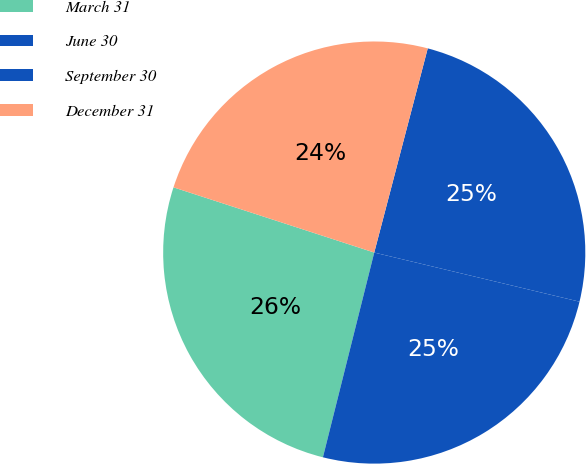Convert chart. <chart><loc_0><loc_0><loc_500><loc_500><pie_chart><fcel>March 31<fcel>June 30<fcel>September 30<fcel>December 31<nl><fcel>26.09%<fcel>25.17%<fcel>24.66%<fcel>24.08%<nl></chart> 